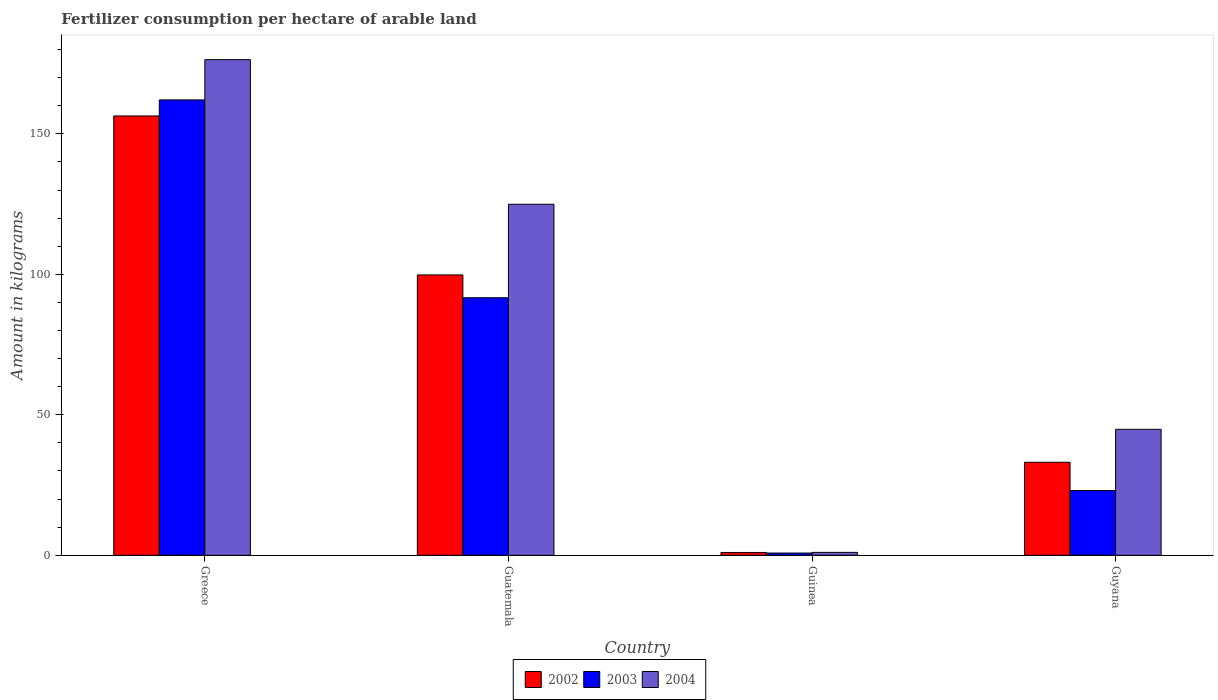How many different coloured bars are there?
Offer a terse response. 3. How many groups of bars are there?
Your answer should be very brief. 4. Are the number of bars per tick equal to the number of legend labels?
Your answer should be compact. Yes. How many bars are there on the 3rd tick from the left?
Your answer should be very brief. 3. How many bars are there on the 4th tick from the right?
Offer a very short reply. 3. What is the amount of fertilizer consumption in 2004 in Guatemala?
Your answer should be compact. 124.95. Across all countries, what is the maximum amount of fertilizer consumption in 2003?
Ensure brevity in your answer.  162.09. Across all countries, what is the minimum amount of fertilizer consumption in 2003?
Your answer should be very brief. 0.79. In which country was the amount of fertilizer consumption in 2003 minimum?
Offer a very short reply. Guinea. What is the total amount of fertilizer consumption in 2003 in the graph?
Your answer should be compact. 277.61. What is the difference between the amount of fertilizer consumption in 2003 in Greece and that in Guinea?
Keep it short and to the point. 161.3. What is the difference between the amount of fertilizer consumption in 2004 in Guinea and the amount of fertilizer consumption in 2002 in Guyana?
Your response must be concise. -32.08. What is the average amount of fertilizer consumption in 2004 per country?
Offer a terse response. 86.81. What is the difference between the amount of fertilizer consumption of/in 2003 and amount of fertilizer consumption of/in 2004 in Guatemala?
Your answer should be compact. -33.27. In how many countries, is the amount of fertilizer consumption in 2002 greater than 170 kg?
Your response must be concise. 0. What is the ratio of the amount of fertilizer consumption in 2003 in Greece to that in Guinea?
Keep it short and to the point. 204.16. Is the difference between the amount of fertilizer consumption in 2003 in Greece and Guinea greater than the difference between the amount of fertilizer consumption in 2004 in Greece and Guinea?
Provide a short and direct response. No. What is the difference between the highest and the second highest amount of fertilizer consumption in 2002?
Provide a succinct answer. -66.68. What is the difference between the highest and the lowest amount of fertilizer consumption in 2003?
Keep it short and to the point. 161.3. In how many countries, is the amount of fertilizer consumption in 2004 greater than the average amount of fertilizer consumption in 2004 taken over all countries?
Ensure brevity in your answer.  2. Is the sum of the amount of fertilizer consumption in 2004 in Greece and Guinea greater than the maximum amount of fertilizer consumption in 2003 across all countries?
Keep it short and to the point. Yes. What does the 3rd bar from the left in Greece represents?
Offer a terse response. 2004. How many bars are there?
Keep it short and to the point. 12. Are all the bars in the graph horizontal?
Provide a short and direct response. No. How many countries are there in the graph?
Give a very brief answer. 4. What is the difference between two consecutive major ticks on the Y-axis?
Offer a very short reply. 50. Where does the legend appear in the graph?
Offer a terse response. Bottom center. How many legend labels are there?
Offer a terse response. 3. What is the title of the graph?
Offer a terse response. Fertilizer consumption per hectare of arable land. Does "1960" appear as one of the legend labels in the graph?
Your answer should be compact. No. What is the label or title of the Y-axis?
Ensure brevity in your answer.  Amount in kilograms. What is the Amount in kilograms of 2002 in Greece?
Your answer should be compact. 156.38. What is the Amount in kilograms in 2003 in Greece?
Make the answer very short. 162.09. What is the Amount in kilograms of 2004 in Greece?
Provide a succinct answer. 176.42. What is the Amount in kilograms of 2002 in Guatemala?
Keep it short and to the point. 99.79. What is the Amount in kilograms in 2003 in Guatemala?
Your response must be concise. 91.67. What is the Amount in kilograms in 2004 in Guatemala?
Your answer should be compact. 124.95. What is the Amount in kilograms in 2002 in Guinea?
Offer a terse response. 1. What is the Amount in kilograms of 2003 in Guinea?
Your response must be concise. 0.79. What is the Amount in kilograms in 2004 in Guinea?
Give a very brief answer. 1.03. What is the Amount in kilograms in 2002 in Guyana?
Your answer should be compact. 33.11. What is the Amount in kilograms of 2003 in Guyana?
Make the answer very short. 23.06. What is the Amount in kilograms in 2004 in Guyana?
Offer a very short reply. 44.83. Across all countries, what is the maximum Amount in kilograms of 2002?
Give a very brief answer. 156.38. Across all countries, what is the maximum Amount in kilograms in 2003?
Keep it short and to the point. 162.09. Across all countries, what is the maximum Amount in kilograms of 2004?
Your answer should be very brief. 176.42. Across all countries, what is the minimum Amount in kilograms of 2002?
Make the answer very short. 1. Across all countries, what is the minimum Amount in kilograms of 2003?
Provide a succinct answer. 0.79. Across all countries, what is the minimum Amount in kilograms in 2004?
Make the answer very short. 1.03. What is the total Amount in kilograms in 2002 in the graph?
Provide a short and direct response. 290.28. What is the total Amount in kilograms of 2003 in the graph?
Your answer should be very brief. 277.61. What is the total Amount in kilograms of 2004 in the graph?
Make the answer very short. 347.23. What is the difference between the Amount in kilograms in 2002 in Greece and that in Guatemala?
Provide a succinct answer. 56.59. What is the difference between the Amount in kilograms in 2003 in Greece and that in Guatemala?
Your answer should be very brief. 70.42. What is the difference between the Amount in kilograms of 2004 in Greece and that in Guatemala?
Keep it short and to the point. 51.47. What is the difference between the Amount in kilograms of 2002 in Greece and that in Guinea?
Keep it short and to the point. 155.37. What is the difference between the Amount in kilograms in 2003 in Greece and that in Guinea?
Keep it short and to the point. 161.3. What is the difference between the Amount in kilograms in 2004 in Greece and that in Guinea?
Give a very brief answer. 175.39. What is the difference between the Amount in kilograms in 2002 in Greece and that in Guyana?
Your response must be concise. 123.27. What is the difference between the Amount in kilograms of 2003 in Greece and that in Guyana?
Provide a succinct answer. 139.03. What is the difference between the Amount in kilograms of 2004 in Greece and that in Guyana?
Your answer should be very brief. 131.58. What is the difference between the Amount in kilograms of 2002 in Guatemala and that in Guinea?
Offer a terse response. 98.79. What is the difference between the Amount in kilograms in 2003 in Guatemala and that in Guinea?
Give a very brief answer. 90.88. What is the difference between the Amount in kilograms of 2004 in Guatemala and that in Guinea?
Your answer should be compact. 123.92. What is the difference between the Amount in kilograms in 2002 in Guatemala and that in Guyana?
Provide a short and direct response. 66.68. What is the difference between the Amount in kilograms in 2003 in Guatemala and that in Guyana?
Your response must be concise. 68.62. What is the difference between the Amount in kilograms in 2004 in Guatemala and that in Guyana?
Your response must be concise. 80.11. What is the difference between the Amount in kilograms in 2002 in Guinea and that in Guyana?
Provide a short and direct response. -32.11. What is the difference between the Amount in kilograms of 2003 in Guinea and that in Guyana?
Your answer should be very brief. -22.26. What is the difference between the Amount in kilograms in 2004 in Guinea and that in Guyana?
Offer a very short reply. -43.8. What is the difference between the Amount in kilograms of 2002 in Greece and the Amount in kilograms of 2003 in Guatemala?
Make the answer very short. 64.71. What is the difference between the Amount in kilograms of 2002 in Greece and the Amount in kilograms of 2004 in Guatemala?
Your response must be concise. 31.43. What is the difference between the Amount in kilograms of 2003 in Greece and the Amount in kilograms of 2004 in Guatemala?
Offer a very short reply. 37.14. What is the difference between the Amount in kilograms of 2002 in Greece and the Amount in kilograms of 2003 in Guinea?
Keep it short and to the point. 155.58. What is the difference between the Amount in kilograms of 2002 in Greece and the Amount in kilograms of 2004 in Guinea?
Ensure brevity in your answer.  155.35. What is the difference between the Amount in kilograms in 2003 in Greece and the Amount in kilograms in 2004 in Guinea?
Keep it short and to the point. 161.06. What is the difference between the Amount in kilograms of 2002 in Greece and the Amount in kilograms of 2003 in Guyana?
Ensure brevity in your answer.  133.32. What is the difference between the Amount in kilograms in 2002 in Greece and the Amount in kilograms in 2004 in Guyana?
Provide a succinct answer. 111.54. What is the difference between the Amount in kilograms in 2003 in Greece and the Amount in kilograms in 2004 in Guyana?
Keep it short and to the point. 117.26. What is the difference between the Amount in kilograms of 2002 in Guatemala and the Amount in kilograms of 2003 in Guinea?
Offer a very short reply. 99. What is the difference between the Amount in kilograms in 2002 in Guatemala and the Amount in kilograms in 2004 in Guinea?
Give a very brief answer. 98.76. What is the difference between the Amount in kilograms of 2003 in Guatemala and the Amount in kilograms of 2004 in Guinea?
Provide a short and direct response. 90.64. What is the difference between the Amount in kilograms of 2002 in Guatemala and the Amount in kilograms of 2003 in Guyana?
Give a very brief answer. 76.73. What is the difference between the Amount in kilograms of 2002 in Guatemala and the Amount in kilograms of 2004 in Guyana?
Ensure brevity in your answer.  54.96. What is the difference between the Amount in kilograms in 2003 in Guatemala and the Amount in kilograms in 2004 in Guyana?
Provide a short and direct response. 46.84. What is the difference between the Amount in kilograms of 2002 in Guinea and the Amount in kilograms of 2003 in Guyana?
Offer a terse response. -22.05. What is the difference between the Amount in kilograms in 2002 in Guinea and the Amount in kilograms in 2004 in Guyana?
Your answer should be very brief. -43.83. What is the difference between the Amount in kilograms of 2003 in Guinea and the Amount in kilograms of 2004 in Guyana?
Provide a succinct answer. -44.04. What is the average Amount in kilograms of 2002 per country?
Your answer should be very brief. 72.57. What is the average Amount in kilograms in 2003 per country?
Offer a very short reply. 69.4. What is the average Amount in kilograms of 2004 per country?
Offer a terse response. 86.81. What is the difference between the Amount in kilograms of 2002 and Amount in kilograms of 2003 in Greece?
Provide a succinct answer. -5.71. What is the difference between the Amount in kilograms of 2002 and Amount in kilograms of 2004 in Greece?
Provide a short and direct response. -20.04. What is the difference between the Amount in kilograms in 2003 and Amount in kilograms in 2004 in Greece?
Offer a very short reply. -14.33. What is the difference between the Amount in kilograms in 2002 and Amount in kilograms in 2003 in Guatemala?
Provide a short and direct response. 8.12. What is the difference between the Amount in kilograms in 2002 and Amount in kilograms in 2004 in Guatemala?
Provide a short and direct response. -25.16. What is the difference between the Amount in kilograms in 2003 and Amount in kilograms in 2004 in Guatemala?
Make the answer very short. -33.27. What is the difference between the Amount in kilograms in 2002 and Amount in kilograms in 2003 in Guinea?
Provide a succinct answer. 0.21. What is the difference between the Amount in kilograms in 2002 and Amount in kilograms in 2004 in Guinea?
Offer a very short reply. -0.03. What is the difference between the Amount in kilograms of 2003 and Amount in kilograms of 2004 in Guinea?
Keep it short and to the point. -0.24. What is the difference between the Amount in kilograms of 2002 and Amount in kilograms of 2003 in Guyana?
Your answer should be very brief. 10.06. What is the difference between the Amount in kilograms in 2002 and Amount in kilograms in 2004 in Guyana?
Provide a short and direct response. -11.72. What is the difference between the Amount in kilograms of 2003 and Amount in kilograms of 2004 in Guyana?
Your answer should be compact. -21.78. What is the ratio of the Amount in kilograms of 2002 in Greece to that in Guatemala?
Provide a short and direct response. 1.57. What is the ratio of the Amount in kilograms of 2003 in Greece to that in Guatemala?
Ensure brevity in your answer.  1.77. What is the ratio of the Amount in kilograms of 2004 in Greece to that in Guatemala?
Offer a terse response. 1.41. What is the ratio of the Amount in kilograms of 2002 in Greece to that in Guinea?
Make the answer very short. 155.73. What is the ratio of the Amount in kilograms of 2003 in Greece to that in Guinea?
Ensure brevity in your answer.  204.16. What is the ratio of the Amount in kilograms of 2004 in Greece to that in Guinea?
Your answer should be compact. 171.25. What is the ratio of the Amount in kilograms of 2002 in Greece to that in Guyana?
Make the answer very short. 4.72. What is the ratio of the Amount in kilograms in 2003 in Greece to that in Guyana?
Your answer should be very brief. 7.03. What is the ratio of the Amount in kilograms of 2004 in Greece to that in Guyana?
Provide a succinct answer. 3.94. What is the ratio of the Amount in kilograms of 2002 in Guatemala to that in Guinea?
Keep it short and to the point. 99.37. What is the ratio of the Amount in kilograms in 2003 in Guatemala to that in Guinea?
Offer a very short reply. 115.46. What is the ratio of the Amount in kilograms of 2004 in Guatemala to that in Guinea?
Offer a terse response. 121.28. What is the ratio of the Amount in kilograms of 2002 in Guatemala to that in Guyana?
Make the answer very short. 3.01. What is the ratio of the Amount in kilograms in 2003 in Guatemala to that in Guyana?
Keep it short and to the point. 3.98. What is the ratio of the Amount in kilograms of 2004 in Guatemala to that in Guyana?
Provide a succinct answer. 2.79. What is the ratio of the Amount in kilograms of 2002 in Guinea to that in Guyana?
Keep it short and to the point. 0.03. What is the ratio of the Amount in kilograms in 2003 in Guinea to that in Guyana?
Provide a succinct answer. 0.03. What is the ratio of the Amount in kilograms in 2004 in Guinea to that in Guyana?
Keep it short and to the point. 0.02. What is the difference between the highest and the second highest Amount in kilograms in 2002?
Keep it short and to the point. 56.59. What is the difference between the highest and the second highest Amount in kilograms of 2003?
Offer a very short reply. 70.42. What is the difference between the highest and the second highest Amount in kilograms in 2004?
Your response must be concise. 51.47. What is the difference between the highest and the lowest Amount in kilograms of 2002?
Your answer should be compact. 155.37. What is the difference between the highest and the lowest Amount in kilograms of 2003?
Provide a succinct answer. 161.3. What is the difference between the highest and the lowest Amount in kilograms of 2004?
Keep it short and to the point. 175.39. 